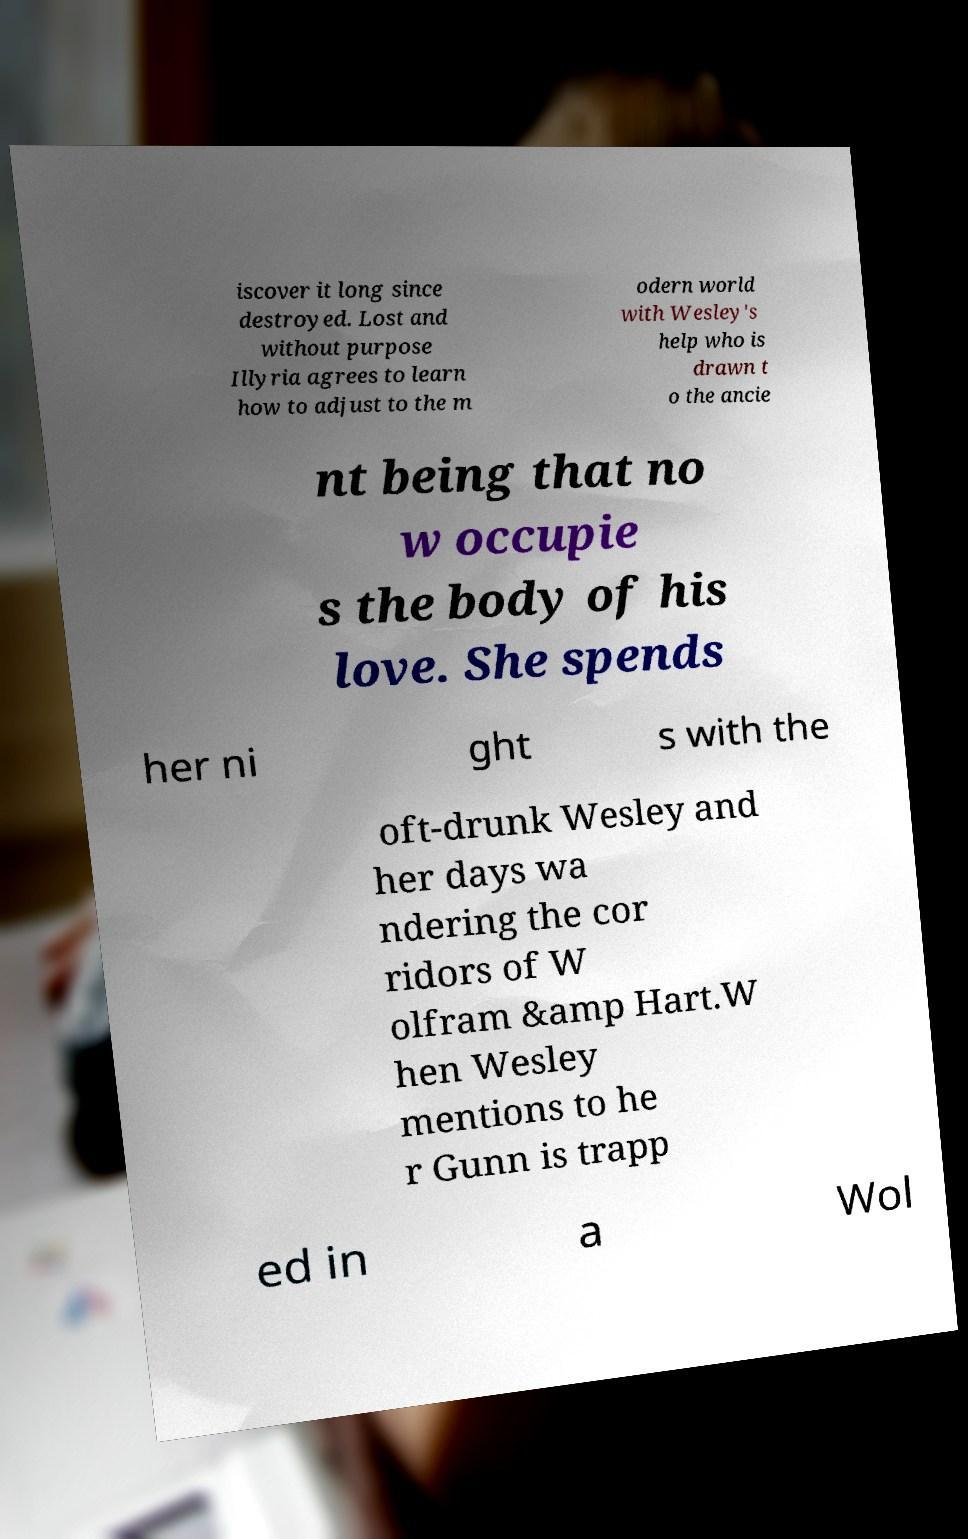Please read and relay the text visible in this image. What does it say? iscover it long since destroyed. Lost and without purpose Illyria agrees to learn how to adjust to the m odern world with Wesley's help who is drawn t o the ancie nt being that no w occupie s the body of his love. She spends her ni ght s with the oft-drunk Wesley and her days wa ndering the cor ridors of W olfram &amp Hart.W hen Wesley mentions to he r Gunn is trapp ed in a Wol 